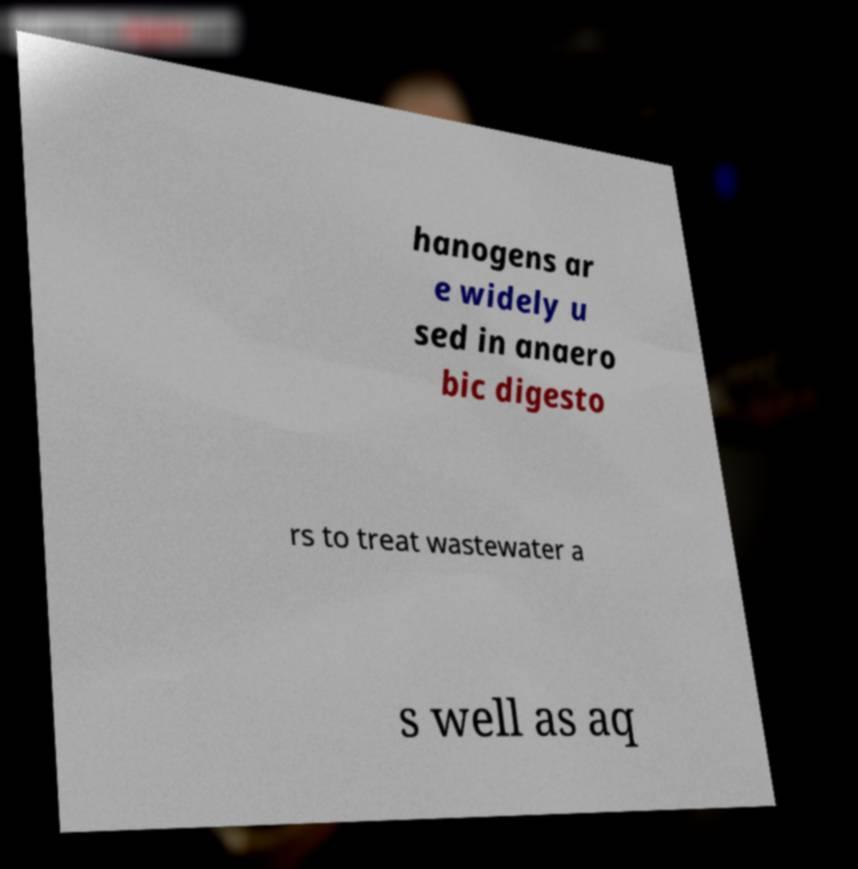For documentation purposes, I need the text within this image transcribed. Could you provide that? hanogens ar e widely u sed in anaero bic digesto rs to treat wastewater a s well as aq 